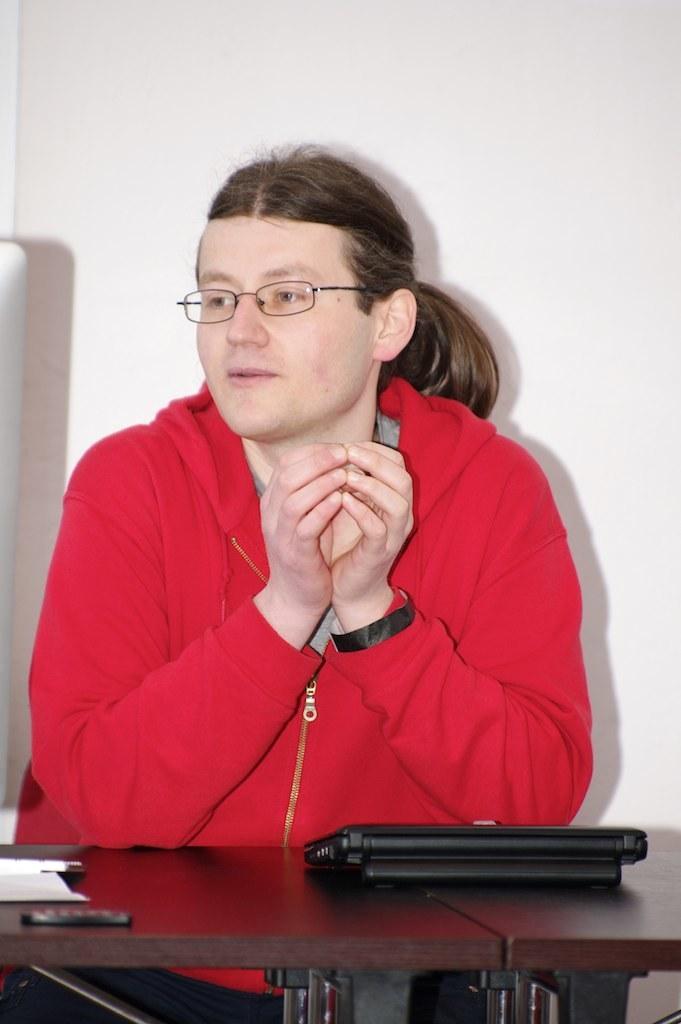Could you give a brief overview of what you see in this image? In this picture I can see there is a person sitting and wearing a red color coat and there are wearing spectacles and looking at left and there is a table in front of the person and there is a white backdrop. 